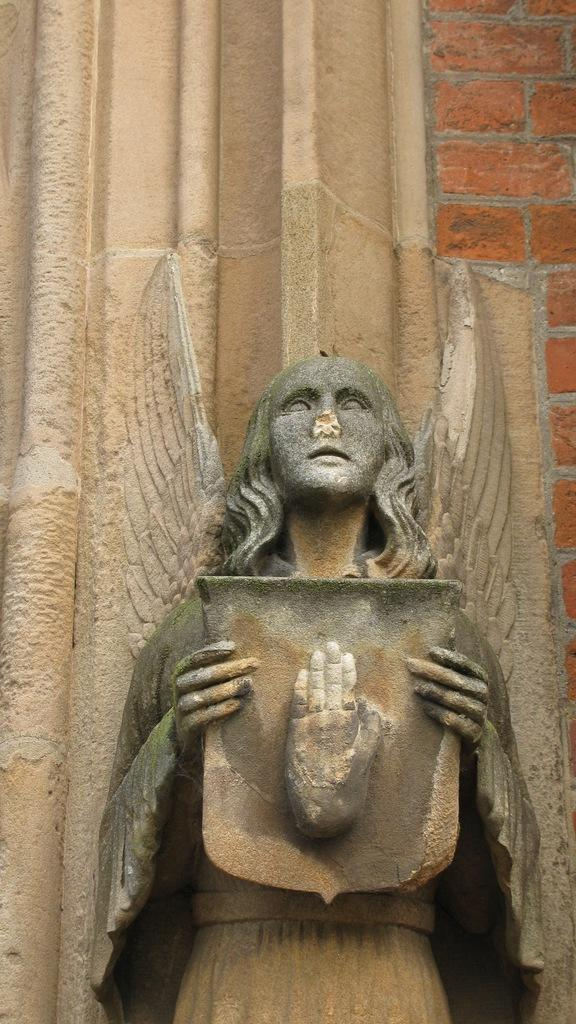What is the main subject in the image? There is a statue in the image. Can you describe the colors of the statue? The statue has brown and grey colors. What can be seen in the background of the image? The background of the image includes a wall. What colors are present on the wall? The wall has cream and brown colors. Is there a bath visible in the image? No, there is no bath present in the image. Is there any indication of a war or conflict in the image? No, there is no indication of a war or conflict in the image. 